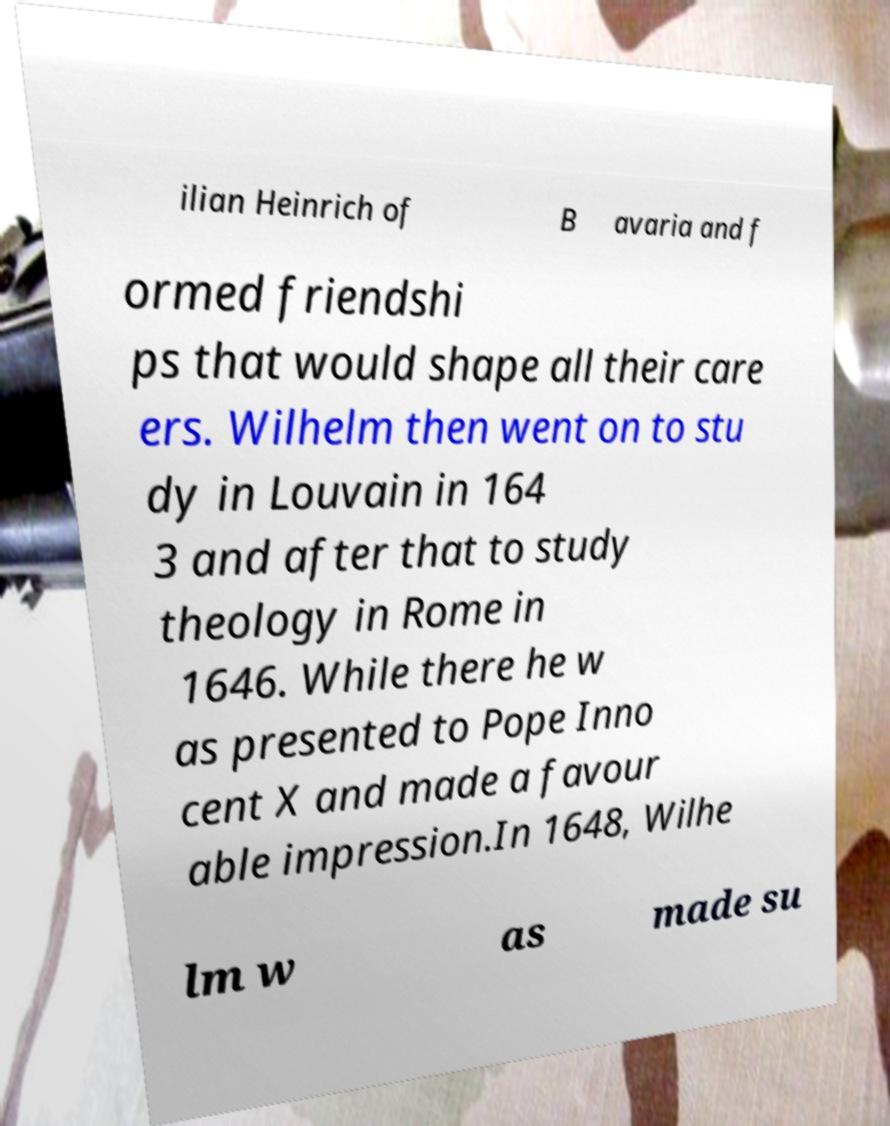Please identify and transcribe the text found in this image. ilian Heinrich of B avaria and f ormed friendshi ps that would shape all their care ers. Wilhelm then went on to stu dy in Louvain in 164 3 and after that to study theology in Rome in 1646. While there he w as presented to Pope Inno cent X and made a favour able impression.In 1648, Wilhe lm w as made su 